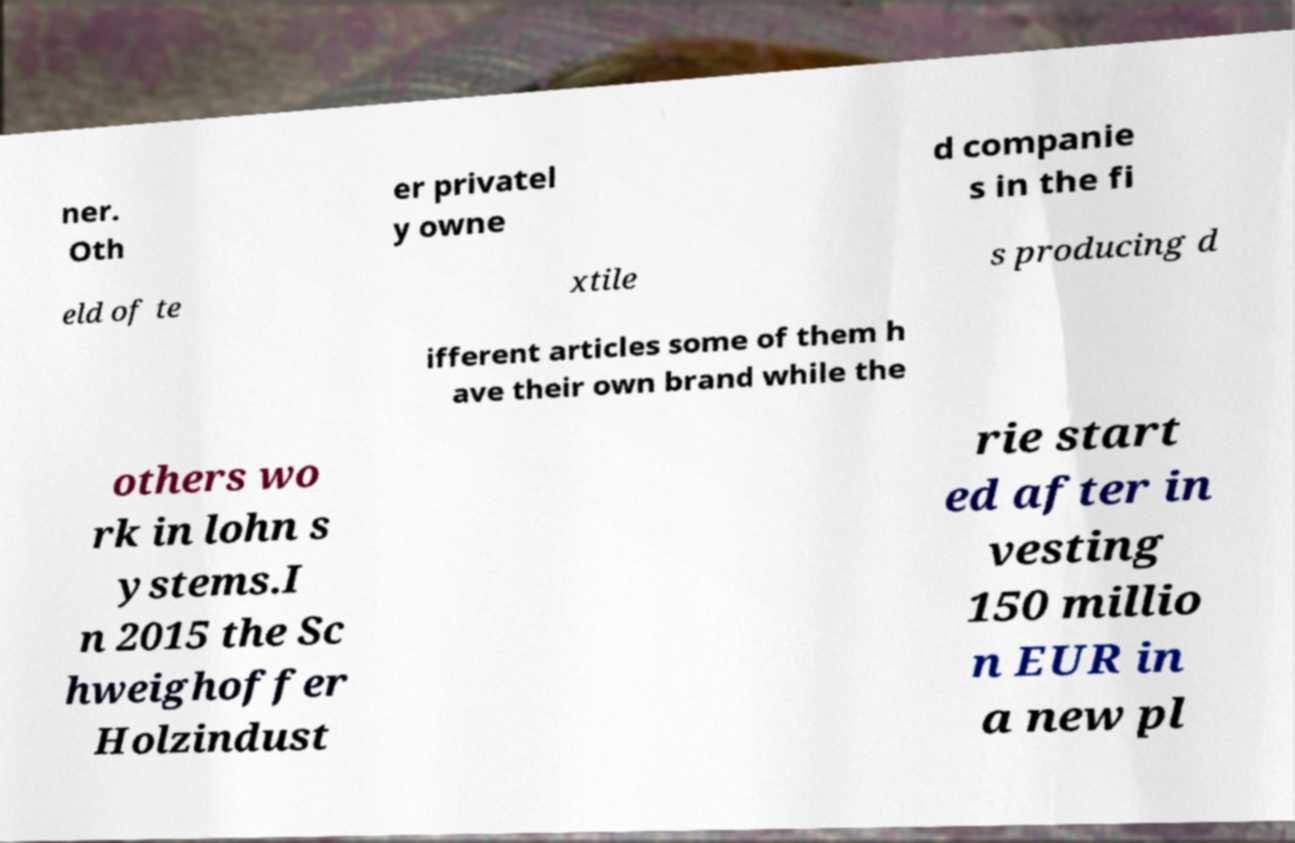Can you accurately transcribe the text from the provided image for me? ner. Oth er privatel y owne d companie s in the fi eld of te xtile s producing d ifferent articles some of them h ave their own brand while the others wo rk in lohn s ystems.I n 2015 the Sc hweighoffer Holzindust rie start ed after in vesting 150 millio n EUR in a new pl 